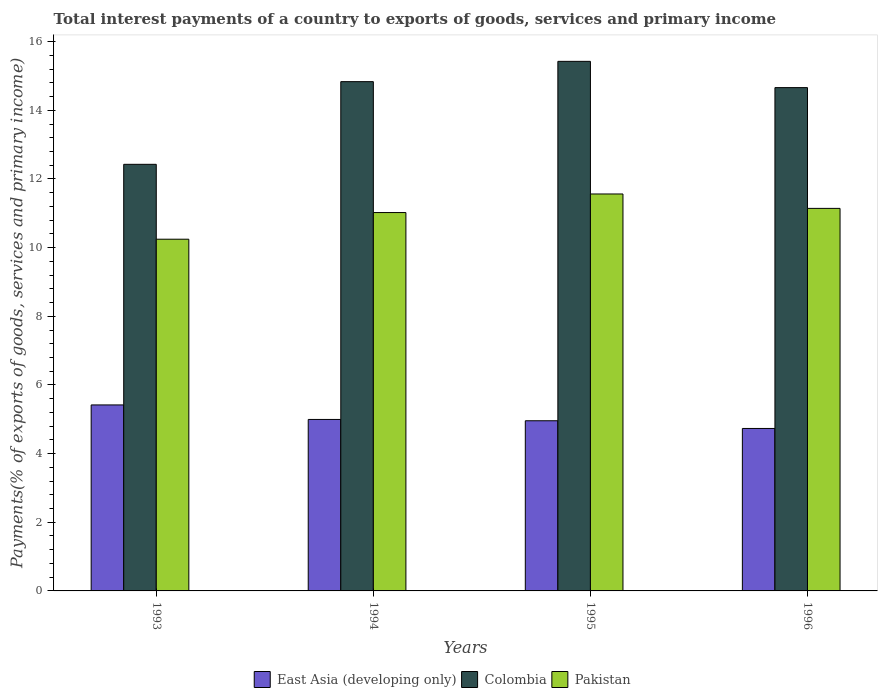Are the number of bars per tick equal to the number of legend labels?
Offer a very short reply. Yes. Are the number of bars on each tick of the X-axis equal?
Ensure brevity in your answer.  Yes. How many bars are there on the 3rd tick from the right?
Offer a terse response. 3. In how many cases, is the number of bars for a given year not equal to the number of legend labels?
Give a very brief answer. 0. What is the total interest payments in Colombia in 1994?
Provide a succinct answer. 14.84. Across all years, what is the maximum total interest payments in East Asia (developing only)?
Make the answer very short. 5.42. Across all years, what is the minimum total interest payments in Colombia?
Keep it short and to the point. 12.43. What is the total total interest payments in Colombia in the graph?
Keep it short and to the point. 57.35. What is the difference between the total interest payments in Pakistan in 1995 and that in 1996?
Keep it short and to the point. 0.42. What is the difference between the total interest payments in Pakistan in 1996 and the total interest payments in Colombia in 1995?
Make the answer very short. -4.28. What is the average total interest payments in Colombia per year?
Your response must be concise. 14.34. In the year 1994, what is the difference between the total interest payments in East Asia (developing only) and total interest payments in Pakistan?
Your answer should be very brief. -6.03. In how many years, is the total interest payments in Colombia greater than 9.6 %?
Ensure brevity in your answer.  4. What is the ratio of the total interest payments in Colombia in 1993 to that in 1995?
Your response must be concise. 0.81. Is the total interest payments in Colombia in 1994 less than that in 1996?
Ensure brevity in your answer.  No. Is the difference between the total interest payments in East Asia (developing only) in 1995 and 1996 greater than the difference between the total interest payments in Pakistan in 1995 and 1996?
Make the answer very short. No. What is the difference between the highest and the second highest total interest payments in East Asia (developing only)?
Give a very brief answer. 0.42. What is the difference between the highest and the lowest total interest payments in Pakistan?
Provide a succinct answer. 1.32. What does the 1st bar from the left in 1993 represents?
Your response must be concise. East Asia (developing only). Are all the bars in the graph horizontal?
Give a very brief answer. No. What is the difference between two consecutive major ticks on the Y-axis?
Give a very brief answer. 2. Are the values on the major ticks of Y-axis written in scientific E-notation?
Give a very brief answer. No. Where does the legend appear in the graph?
Keep it short and to the point. Bottom center. How are the legend labels stacked?
Make the answer very short. Horizontal. What is the title of the graph?
Ensure brevity in your answer.  Total interest payments of a country to exports of goods, services and primary income. What is the label or title of the Y-axis?
Offer a terse response. Payments(% of exports of goods, services and primary income). What is the Payments(% of exports of goods, services and primary income) in East Asia (developing only) in 1993?
Ensure brevity in your answer.  5.42. What is the Payments(% of exports of goods, services and primary income) of Colombia in 1993?
Provide a succinct answer. 12.43. What is the Payments(% of exports of goods, services and primary income) in Pakistan in 1993?
Your answer should be compact. 10.25. What is the Payments(% of exports of goods, services and primary income) of East Asia (developing only) in 1994?
Provide a short and direct response. 4.99. What is the Payments(% of exports of goods, services and primary income) of Colombia in 1994?
Provide a short and direct response. 14.84. What is the Payments(% of exports of goods, services and primary income) of Pakistan in 1994?
Your answer should be very brief. 11.02. What is the Payments(% of exports of goods, services and primary income) in East Asia (developing only) in 1995?
Your answer should be very brief. 4.96. What is the Payments(% of exports of goods, services and primary income) in Colombia in 1995?
Keep it short and to the point. 15.43. What is the Payments(% of exports of goods, services and primary income) in Pakistan in 1995?
Give a very brief answer. 11.56. What is the Payments(% of exports of goods, services and primary income) of East Asia (developing only) in 1996?
Give a very brief answer. 4.73. What is the Payments(% of exports of goods, services and primary income) of Colombia in 1996?
Offer a very short reply. 14.66. What is the Payments(% of exports of goods, services and primary income) in Pakistan in 1996?
Give a very brief answer. 11.14. Across all years, what is the maximum Payments(% of exports of goods, services and primary income) in East Asia (developing only)?
Your answer should be very brief. 5.42. Across all years, what is the maximum Payments(% of exports of goods, services and primary income) of Colombia?
Your answer should be compact. 15.43. Across all years, what is the maximum Payments(% of exports of goods, services and primary income) in Pakistan?
Give a very brief answer. 11.56. Across all years, what is the minimum Payments(% of exports of goods, services and primary income) in East Asia (developing only)?
Your response must be concise. 4.73. Across all years, what is the minimum Payments(% of exports of goods, services and primary income) in Colombia?
Your answer should be very brief. 12.43. Across all years, what is the minimum Payments(% of exports of goods, services and primary income) in Pakistan?
Ensure brevity in your answer.  10.25. What is the total Payments(% of exports of goods, services and primary income) of East Asia (developing only) in the graph?
Your answer should be compact. 20.1. What is the total Payments(% of exports of goods, services and primary income) in Colombia in the graph?
Keep it short and to the point. 57.35. What is the total Payments(% of exports of goods, services and primary income) in Pakistan in the graph?
Your answer should be compact. 43.97. What is the difference between the Payments(% of exports of goods, services and primary income) of East Asia (developing only) in 1993 and that in 1994?
Offer a very short reply. 0.42. What is the difference between the Payments(% of exports of goods, services and primary income) in Colombia in 1993 and that in 1994?
Ensure brevity in your answer.  -2.41. What is the difference between the Payments(% of exports of goods, services and primary income) of Pakistan in 1993 and that in 1994?
Make the answer very short. -0.78. What is the difference between the Payments(% of exports of goods, services and primary income) in East Asia (developing only) in 1993 and that in 1995?
Provide a short and direct response. 0.46. What is the difference between the Payments(% of exports of goods, services and primary income) in Colombia in 1993 and that in 1995?
Your answer should be compact. -3. What is the difference between the Payments(% of exports of goods, services and primary income) of Pakistan in 1993 and that in 1995?
Offer a very short reply. -1.32. What is the difference between the Payments(% of exports of goods, services and primary income) of East Asia (developing only) in 1993 and that in 1996?
Provide a short and direct response. 0.69. What is the difference between the Payments(% of exports of goods, services and primary income) of Colombia in 1993 and that in 1996?
Provide a short and direct response. -2.23. What is the difference between the Payments(% of exports of goods, services and primary income) of Pakistan in 1993 and that in 1996?
Your answer should be very brief. -0.9. What is the difference between the Payments(% of exports of goods, services and primary income) of East Asia (developing only) in 1994 and that in 1995?
Provide a succinct answer. 0.04. What is the difference between the Payments(% of exports of goods, services and primary income) in Colombia in 1994 and that in 1995?
Provide a short and direct response. -0.59. What is the difference between the Payments(% of exports of goods, services and primary income) in Pakistan in 1994 and that in 1995?
Make the answer very short. -0.54. What is the difference between the Payments(% of exports of goods, services and primary income) of East Asia (developing only) in 1994 and that in 1996?
Provide a short and direct response. 0.26. What is the difference between the Payments(% of exports of goods, services and primary income) of Colombia in 1994 and that in 1996?
Provide a short and direct response. 0.17. What is the difference between the Payments(% of exports of goods, services and primary income) in Pakistan in 1994 and that in 1996?
Give a very brief answer. -0.12. What is the difference between the Payments(% of exports of goods, services and primary income) of East Asia (developing only) in 1995 and that in 1996?
Offer a terse response. 0.22. What is the difference between the Payments(% of exports of goods, services and primary income) of Colombia in 1995 and that in 1996?
Your answer should be very brief. 0.77. What is the difference between the Payments(% of exports of goods, services and primary income) of Pakistan in 1995 and that in 1996?
Make the answer very short. 0.42. What is the difference between the Payments(% of exports of goods, services and primary income) in East Asia (developing only) in 1993 and the Payments(% of exports of goods, services and primary income) in Colombia in 1994?
Offer a terse response. -9.42. What is the difference between the Payments(% of exports of goods, services and primary income) in East Asia (developing only) in 1993 and the Payments(% of exports of goods, services and primary income) in Pakistan in 1994?
Your response must be concise. -5.6. What is the difference between the Payments(% of exports of goods, services and primary income) in Colombia in 1993 and the Payments(% of exports of goods, services and primary income) in Pakistan in 1994?
Your response must be concise. 1.4. What is the difference between the Payments(% of exports of goods, services and primary income) of East Asia (developing only) in 1993 and the Payments(% of exports of goods, services and primary income) of Colombia in 1995?
Offer a terse response. -10.01. What is the difference between the Payments(% of exports of goods, services and primary income) of East Asia (developing only) in 1993 and the Payments(% of exports of goods, services and primary income) of Pakistan in 1995?
Make the answer very short. -6.14. What is the difference between the Payments(% of exports of goods, services and primary income) of Colombia in 1993 and the Payments(% of exports of goods, services and primary income) of Pakistan in 1995?
Make the answer very short. 0.86. What is the difference between the Payments(% of exports of goods, services and primary income) in East Asia (developing only) in 1993 and the Payments(% of exports of goods, services and primary income) in Colombia in 1996?
Provide a short and direct response. -9.24. What is the difference between the Payments(% of exports of goods, services and primary income) of East Asia (developing only) in 1993 and the Payments(% of exports of goods, services and primary income) of Pakistan in 1996?
Offer a terse response. -5.73. What is the difference between the Payments(% of exports of goods, services and primary income) of Colombia in 1993 and the Payments(% of exports of goods, services and primary income) of Pakistan in 1996?
Ensure brevity in your answer.  1.28. What is the difference between the Payments(% of exports of goods, services and primary income) of East Asia (developing only) in 1994 and the Payments(% of exports of goods, services and primary income) of Colombia in 1995?
Your answer should be compact. -10.43. What is the difference between the Payments(% of exports of goods, services and primary income) in East Asia (developing only) in 1994 and the Payments(% of exports of goods, services and primary income) in Pakistan in 1995?
Keep it short and to the point. -6.57. What is the difference between the Payments(% of exports of goods, services and primary income) of Colombia in 1994 and the Payments(% of exports of goods, services and primary income) of Pakistan in 1995?
Provide a short and direct response. 3.27. What is the difference between the Payments(% of exports of goods, services and primary income) of East Asia (developing only) in 1994 and the Payments(% of exports of goods, services and primary income) of Colombia in 1996?
Ensure brevity in your answer.  -9.67. What is the difference between the Payments(% of exports of goods, services and primary income) of East Asia (developing only) in 1994 and the Payments(% of exports of goods, services and primary income) of Pakistan in 1996?
Provide a short and direct response. -6.15. What is the difference between the Payments(% of exports of goods, services and primary income) in Colombia in 1994 and the Payments(% of exports of goods, services and primary income) in Pakistan in 1996?
Ensure brevity in your answer.  3.69. What is the difference between the Payments(% of exports of goods, services and primary income) in East Asia (developing only) in 1995 and the Payments(% of exports of goods, services and primary income) in Colombia in 1996?
Ensure brevity in your answer.  -9.7. What is the difference between the Payments(% of exports of goods, services and primary income) of East Asia (developing only) in 1995 and the Payments(% of exports of goods, services and primary income) of Pakistan in 1996?
Provide a short and direct response. -6.19. What is the difference between the Payments(% of exports of goods, services and primary income) in Colombia in 1995 and the Payments(% of exports of goods, services and primary income) in Pakistan in 1996?
Provide a short and direct response. 4.28. What is the average Payments(% of exports of goods, services and primary income) in East Asia (developing only) per year?
Provide a short and direct response. 5.03. What is the average Payments(% of exports of goods, services and primary income) of Colombia per year?
Your response must be concise. 14.34. What is the average Payments(% of exports of goods, services and primary income) in Pakistan per year?
Your answer should be very brief. 10.99. In the year 1993, what is the difference between the Payments(% of exports of goods, services and primary income) in East Asia (developing only) and Payments(% of exports of goods, services and primary income) in Colombia?
Provide a short and direct response. -7.01. In the year 1993, what is the difference between the Payments(% of exports of goods, services and primary income) in East Asia (developing only) and Payments(% of exports of goods, services and primary income) in Pakistan?
Provide a succinct answer. -4.83. In the year 1993, what is the difference between the Payments(% of exports of goods, services and primary income) of Colombia and Payments(% of exports of goods, services and primary income) of Pakistan?
Your response must be concise. 2.18. In the year 1994, what is the difference between the Payments(% of exports of goods, services and primary income) of East Asia (developing only) and Payments(% of exports of goods, services and primary income) of Colombia?
Provide a short and direct response. -9.84. In the year 1994, what is the difference between the Payments(% of exports of goods, services and primary income) in East Asia (developing only) and Payments(% of exports of goods, services and primary income) in Pakistan?
Make the answer very short. -6.03. In the year 1994, what is the difference between the Payments(% of exports of goods, services and primary income) in Colombia and Payments(% of exports of goods, services and primary income) in Pakistan?
Ensure brevity in your answer.  3.81. In the year 1995, what is the difference between the Payments(% of exports of goods, services and primary income) in East Asia (developing only) and Payments(% of exports of goods, services and primary income) in Colombia?
Give a very brief answer. -10.47. In the year 1995, what is the difference between the Payments(% of exports of goods, services and primary income) of East Asia (developing only) and Payments(% of exports of goods, services and primary income) of Pakistan?
Offer a terse response. -6.61. In the year 1995, what is the difference between the Payments(% of exports of goods, services and primary income) of Colombia and Payments(% of exports of goods, services and primary income) of Pakistan?
Your answer should be compact. 3.86. In the year 1996, what is the difference between the Payments(% of exports of goods, services and primary income) in East Asia (developing only) and Payments(% of exports of goods, services and primary income) in Colombia?
Your answer should be compact. -9.93. In the year 1996, what is the difference between the Payments(% of exports of goods, services and primary income) of East Asia (developing only) and Payments(% of exports of goods, services and primary income) of Pakistan?
Your response must be concise. -6.41. In the year 1996, what is the difference between the Payments(% of exports of goods, services and primary income) in Colombia and Payments(% of exports of goods, services and primary income) in Pakistan?
Ensure brevity in your answer.  3.52. What is the ratio of the Payments(% of exports of goods, services and primary income) in East Asia (developing only) in 1993 to that in 1994?
Your response must be concise. 1.08. What is the ratio of the Payments(% of exports of goods, services and primary income) in Colombia in 1993 to that in 1994?
Offer a very short reply. 0.84. What is the ratio of the Payments(% of exports of goods, services and primary income) of Pakistan in 1993 to that in 1994?
Your answer should be very brief. 0.93. What is the ratio of the Payments(% of exports of goods, services and primary income) in East Asia (developing only) in 1993 to that in 1995?
Provide a succinct answer. 1.09. What is the ratio of the Payments(% of exports of goods, services and primary income) of Colombia in 1993 to that in 1995?
Provide a succinct answer. 0.81. What is the ratio of the Payments(% of exports of goods, services and primary income) in Pakistan in 1993 to that in 1995?
Your answer should be compact. 0.89. What is the ratio of the Payments(% of exports of goods, services and primary income) of East Asia (developing only) in 1993 to that in 1996?
Provide a succinct answer. 1.14. What is the ratio of the Payments(% of exports of goods, services and primary income) in Colombia in 1993 to that in 1996?
Your response must be concise. 0.85. What is the ratio of the Payments(% of exports of goods, services and primary income) of Pakistan in 1993 to that in 1996?
Provide a short and direct response. 0.92. What is the ratio of the Payments(% of exports of goods, services and primary income) of East Asia (developing only) in 1994 to that in 1995?
Offer a terse response. 1.01. What is the ratio of the Payments(% of exports of goods, services and primary income) in Colombia in 1994 to that in 1995?
Provide a succinct answer. 0.96. What is the ratio of the Payments(% of exports of goods, services and primary income) of Pakistan in 1994 to that in 1995?
Your answer should be compact. 0.95. What is the ratio of the Payments(% of exports of goods, services and primary income) of East Asia (developing only) in 1994 to that in 1996?
Make the answer very short. 1.06. What is the ratio of the Payments(% of exports of goods, services and primary income) of Colombia in 1994 to that in 1996?
Offer a terse response. 1.01. What is the ratio of the Payments(% of exports of goods, services and primary income) of Pakistan in 1994 to that in 1996?
Your answer should be very brief. 0.99. What is the ratio of the Payments(% of exports of goods, services and primary income) in East Asia (developing only) in 1995 to that in 1996?
Your answer should be very brief. 1.05. What is the ratio of the Payments(% of exports of goods, services and primary income) of Colombia in 1995 to that in 1996?
Your answer should be very brief. 1.05. What is the ratio of the Payments(% of exports of goods, services and primary income) in Pakistan in 1995 to that in 1996?
Ensure brevity in your answer.  1.04. What is the difference between the highest and the second highest Payments(% of exports of goods, services and primary income) of East Asia (developing only)?
Offer a terse response. 0.42. What is the difference between the highest and the second highest Payments(% of exports of goods, services and primary income) in Colombia?
Your answer should be compact. 0.59. What is the difference between the highest and the second highest Payments(% of exports of goods, services and primary income) in Pakistan?
Provide a short and direct response. 0.42. What is the difference between the highest and the lowest Payments(% of exports of goods, services and primary income) of East Asia (developing only)?
Keep it short and to the point. 0.69. What is the difference between the highest and the lowest Payments(% of exports of goods, services and primary income) in Colombia?
Ensure brevity in your answer.  3. What is the difference between the highest and the lowest Payments(% of exports of goods, services and primary income) in Pakistan?
Make the answer very short. 1.32. 